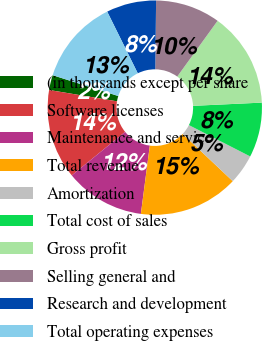<chart> <loc_0><loc_0><loc_500><loc_500><pie_chart><fcel>(in thousands except per share<fcel>Software licenses<fcel>Maintenance and service<fcel>Total revenue<fcel>Amortization<fcel>Total cost of sales<fcel>Gross profit<fcel>Selling general and<fcel>Research and development<fcel>Total operating expenses<nl><fcel>2.26%<fcel>13.53%<fcel>12.03%<fcel>15.04%<fcel>4.51%<fcel>8.27%<fcel>14.29%<fcel>9.77%<fcel>7.52%<fcel>12.78%<nl></chart> 